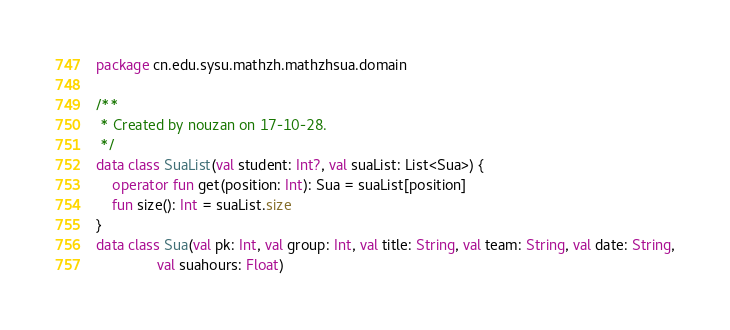Convert code to text. <code><loc_0><loc_0><loc_500><loc_500><_Kotlin_>package cn.edu.sysu.mathzh.mathzhsua.domain

/**
 * Created by nouzan on 17-10-28.
 */
data class SuaList(val student: Int?, val suaList: List<Sua>) {
    operator fun get(position: Int): Sua = suaList[position]
    fun size(): Int = suaList.size
}
data class Sua(val pk: Int, val group: Int, val title: String, val team: String, val date: String,
               val suahours: Float)</code> 